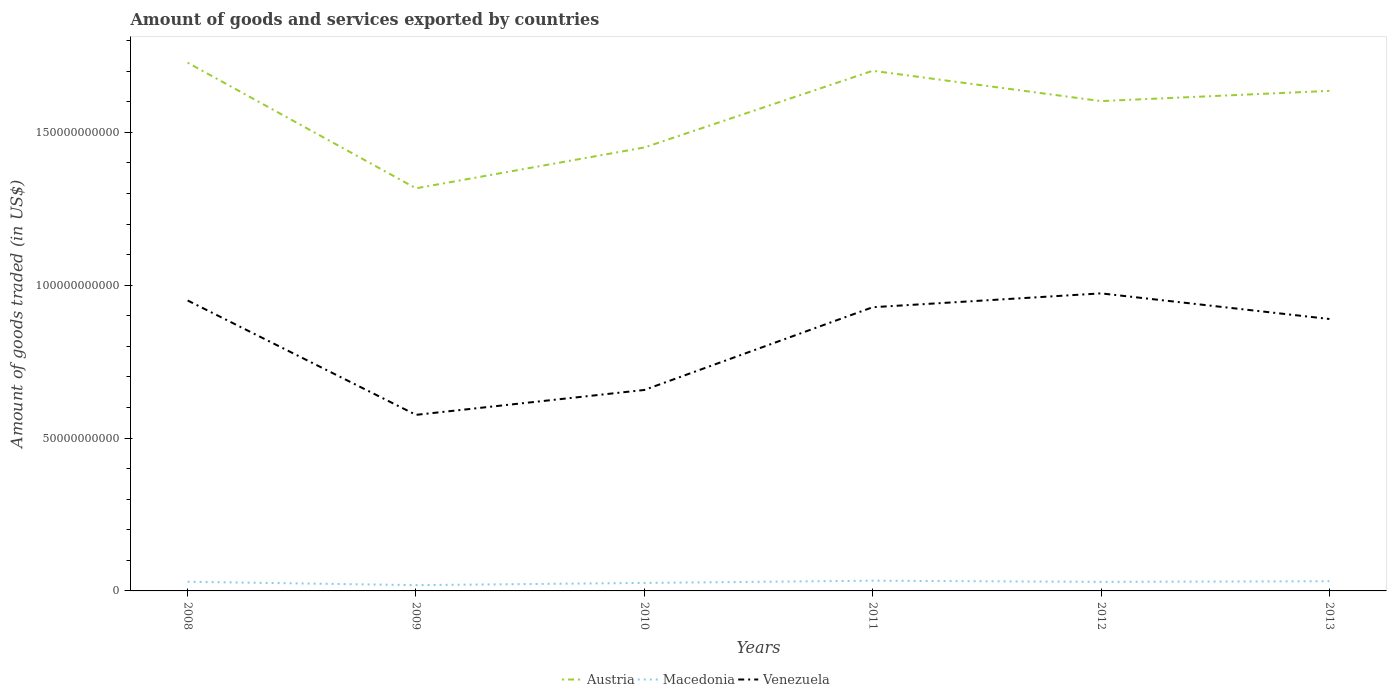Does the line corresponding to Austria intersect with the line corresponding to Macedonia?
Offer a very short reply. No. Is the number of lines equal to the number of legend labels?
Offer a terse response. Yes. Across all years, what is the maximum total amount of goods and services exported in Austria?
Your answer should be compact. 1.32e+11. What is the total total amount of goods and services exported in Austria in the graph?
Your answer should be compact. 9.22e+09. What is the difference between the highest and the second highest total amount of goods and services exported in Austria?
Offer a terse response. 4.11e+1. What is the difference between the highest and the lowest total amount of goods and services exported in Austria?
Provide a succinct answer. 4. How many lines are there?
Offer a very short reply. 3. How many years are there in the graph?
Provide a succinct answer. 6. Does the graph contain any zero values?
Your response must be concise. No. Where does the legend appear in the graph?
Make the answer very short. Bottom center. How are the legend labels stacked?
Provide a succinct answer. Horizontal. What is the title of the graph?
Ensure brevity in your answer.  Amount of goods and services exported by countries. Does "Least developed countries" appear as one of the legend labels in the graph?
Provide a succinct answer. No. What is the label or title of the Y-axis?
Make the answer very short. Amount of goods traded (in US$). What is the Amount of goods traded (in US$) of Austria in 2008?
Your answer should be very brief. 1.73e+11. What is the Amount of goods traded (in US$) of Macedonia in 2008?
Keep it short and to the point. 3.00e+09. What is the Amount of goods traded (in US$) in Venezuela in 2008?
Keep it short and to the point. 9.50e+1. What is the Amount of goods traded (in US$) of Austria in 2009?
Provide a succinct answer. 1.32e+11. What is the Amount of goods traded (in US$) of Macedonia in 2009?
Offer a terse response. 1.89e+09. What is the Amount of goods traded (in US$) in Venezuela in 2009?
Offer a terse response. 5.76e+1. What is the Amount of goods traded (in US$) of Austria in 2010?
Your answer should be compact. 1.45e+11. What is the Amount of goods traded (in US$) in Macedonia in 2010?
Offer a very short reply. 2.62e+09. What is the Amount of goods traded (in US$) in Venezuela in 2010?
Give a very brief answer. 6.57e+1. What is the Amount of goods traded (in US$) in Austria in 2011?
Keep it short and to the point. 1.70e+11. What is the Amount of goods traded (in US$) in Macedonia in 2011?
Your response must be concise. 3.34e+09. What is the Amount of goods traded (in US$) of Venezuela in 2011?
Your answer should be compact. 9.28e+1. What is the Amount of goods traded (in US$) in Austria in 2012?
Ensure brevity in your answer.  1.60e+11. What is the Amount of goods traded (in US$) of Macedonia in 2012?
Offer a terse response. 2.96e+09. What is the Amount of goods traded (in US$) of Venezuela in 2012?
Ensure brevity in your answer.  9.73e+1. What is the Amount of goods traded (in US$) of Austria in 2013?
Make the answer very short. 1.64e+11. What is the Amount of goods traded (in US$) in Macedonia in 2013?
Your answer should be very brief. 3.17e+09. What is the Amount of goods traded (in US$) in Venezuela in 2013?
Provide a succinct answer. 8.90e+1. Across all years, what is the maximum Amount of goods traded (in US$) in Austria?
Your answer should be compact. 1.73e+11. Across all years, what is the maximum Amount of goods traded (in US$) of Macedonia?
Ensure brevity in your answer.  3.34e+09. Across all years, what is the maximum Amount of goods traded (in US$) in Venezuela?
Your answer should be compact. 9.73e+1. Across all years, what is the minimum Amount of goods traded (in US$) in Austria?
Provide a succinct answer. 1.32e+11. Across all years, what is the minimum Amount of goods traded (in US$) in Macedonia?
Your answer should be very brief. 1.89e+09. Across all years, what is the minimum Amount of goods traded (in US$) in Venezuela?
Provide a short and direct response. 5.76e+1. What is the total Amount of goods traded (in US$) of Austria in the graph?
Keep it short and to the point. 9.44e+11. What is the total Amount of goods traded (in US$) in Macedonia in the graph?
Your response must be concise. 1.70e+1. What is the total Amount of goods traded (in US$) of Venezuela in the graph?
Offer a very short reply. 4.97e+11. What is the difference between the Amount of goods traded (in US$) of Austria in 2008 and that in 2009?
Offer a very short reply. 4.11e+1. What is the difference between the Amount of goods traded (in US$) of Macedonia in 2008 and that in 2009?
Ensure brevity in your answer.  1.10e+09. What is the difference between the Amount of goods traded (in US$) in Venezuela in 2008 and that in 2009?
Offer a very short reply. 3.74e+1. What is the difference between the Amount of goods traded (in US$) in Austria in 2008 and that in 2010?
Offer a very short reply. 2.77e+1. What is the difference between the Amount of goods traded (in US$) of Macedonia in 2008 and that in 2010?
Provide a short and direct response. 3.79e+08. What is the difference between the Amount of goods traded (in US$) in Venezuela in 2008 and that in 2010?
Your answer should be compact. 2.93e+1. What is the difference between the Amount of goods traded (in US$) of Austria in 2008 and that in 2011?
Provide a succinct answer. 2.64e+09. What is the difference between the Amount of goods traded (in US$) of Macedonia in 2008 and that in 2011?
Ensure brevity in your answer.  -3.42e+08. What is the difference between the Amount of goods traded (in US$) in Venezuela in 2008 and that in 2011?
Your answer should be compact. 2.21e+09. What is the difference between the Amount of goods traded (in US$) in Austria in 2008 and that in 2012?
Your answer should be compact. 1.26e+1. What is the difference between the Amount of goods traded (in US$) of Macedonia in 2008 and that in 2012?
Your answer should be very brief. 3.56e+07. What is the difference between the Amount of goods traded (in US$) in Venezuela in 2008 and that in 2012?
Your answer should be compact. -2.32e+09. What is the difference between the Amount of goods traded (in US$) of Austria in 2008 and that in 2013?
Provide a succinct answer. 9.22e+09. What is the difference between the Amount of goods traded (in US$) in Macedonia in 2008 and that in 2013?
Keep it short and to the point. -1.70e+08. What is the difference between the Amount of goods traded (in US$) of Venezuela in 2008 and that in 2013?
Give a very brief answer. 6.06e+09. What is the difference between the Amount of goods traded (in US$) of Austria in 2009 and that in 2010?
Your answer should be compact. -1.34e+1. What is the difference between the Amount of goods traded (in US$) in Macedonia in 2009 and that in 2010?
Ensure brevity in your answer.  -7.25e+08. What is the difference between the Amount of goods traded (in US$) of Venezuela in 2009 and that in 2010?
Offer a terse response. -8.14e+09. What is the difference between the Amount of goods traded (in US$) in Austria in 2009 and that in 2011?
Your answer should be very brief. -3.84e+1. What is the difference between the Amount of goods traded (in US$) of Macedonia in 2009 and that in 2011?
Your answer should be compact. -1.45e+09. What is the difference between the Amount of goods traded (in US$) of Venezuela in 2009 and that in 2011?
Provide a succinct answer. -3.52e+1. What is the difference between the Amount of goods traded (in US$) of Austria in 2009 and that in 2012?
Give a very brief answer. -2.85e+1. What is the difference between the Amount of goods traded (in US$) of Macedonia in 2009 and that in 2012?
Offer a very short reply. -1.07e+09. What is the difference between the Amount of goods traded (in US$) of Venezuela in 2009 and that in 2012?
Your answer should be very brief. -3.97e+1. What is the difference between the Amount of goods traded (in US$) of Austria in 2009 and that in 2013?
Your answer should be very brief. -3.19e+1. What is the difference between the Amount of goods traded (in US$) in Macedonia in 2009 and that in 2013?
Provide a succinct answer. -1.27e+09. What is the difference between the Amount of goods traded (in US$) of Venezuela in 2009 and that in 2013?
Provide a short and direct response. -3.14e+1. What is the difference between the Amount of goods traded (in US$) in Austria in 2010 and that in 2011?
Give a very brief answer. -2.51e+1. What is the difference between the Amount of goods traded (in US$) in Macedonia in 2010 and that in 2011?
Ensure brevity in your answer.  -7.21e+08. What is the difference between the Amount of goods traded (in US$) of Venezuela in 2010 and that in 2011?
Offer a very short reply. -2.71e+1. What is the difference between the Amount of goods traded (in US$) of Austria in 2010 and that in 2012?
Keep it short and to the point. -1.52e+1. What is the difference between the Amount of goods traded (in US$) in Macedonia in 2010 and that in 2012?
Offer a terse response. -3.44e+08. What is the difference between the Amount of goods traded (in US$) in Venezuela in 2010 and that in 2012?
Offer a terse response. -3.16e+1. What is the difference between the Amount of goods traded (in US$) of Austria in 2010 and that in 2013?
Your answer should be compact. -1.85e+1. What is the difference between the Amount of goods traded (in US$) in Macedonia in 2010 and that in 2013?
Your answer should be very brief. -5.49e+08. What is the difference between the Amount of goods traded (in US$) in Venezuela in 2010 and that in 2013?
Provide a succinct answer. -2.32e+1. What is the difference between the Amount of goods traded (in US$) of Austria in 2011 and that in 2012?
Offer a terse response. 9.92e+09. What is the difference between the Amount of goods traded (in US$) in Macedonia in 2011 and that in 2012?
Your answer should be very brief. 3.78e+08. What is the difference between the Amount of goods traded (in US$) in Venezuela in 2011 and that in 2012?
Ensure brevity in your answer.  -4.53e+09. What is the difference between the Amount of goods traded (in US$) of Austria in 2011 and that in 2013?
Ensure brevity in your answer.  6.57e+09. What is the difference between the Amount of goods traded (in US$) of Macedonia in 2011 and that in 2013?
Your answer should be compact. 1.72e+08. What is the difference between the Amount of goods traded (in US$) of Venezuela in 2011 and that in 2013?
Your answer should be very brief. 3.85e+09. What is the difference between the Amount of goods traded (in US$) in Austria in 2012 and that in 2013?
Your answer should be very brief. -3.34e+09. What is the difference between the Amount of goods traded (in US$) of Macedonia in 2012 and that in 2013?
Make the answer very short. -2.06e+08. What is the difference between the Amount of goods traded (in US$) of Venezuela in 2012 and that in 2013?
Keep it short and to the point. 8.38e+09. What is the difference between the Amount of goods traded (in US$) in Austria in 2008 and the Amount of goods traded (in US$) in Macedonia in 2009?
Make the answer very short. 1.71e+11. What is the difference between the Amount of goods traded (in US$) in Austria in 2008 and the Amount of goods traded (in US$) in Venezuela in 2009?
Provide a succinct answer. 1.15e+11. What is the difference between the Amount of goods traded (in US$) in Macedonia in 2008 and the Amount of goods traded (in US$) in Venezuela in 2009?
Provide a short and direct response. -5.46e+1. What is the difference between the Amount of goods traded (in US$) in Austria in 2008 and the Amount of goods traded (in US$) in Macedonia in 2010?
Keep it short and to the point. 1.70e+11. What is the difference between the Amount of goods traded (in US$) in Austria in 2008 and the Amount of goods traded (in US$) in Venezuela in 2010?
Provide a short and direct response. 1.07e+11. What is the difference between the Amount of goods traded (in US$) of Macedonia in 2008 and the Amount of goods traded (in US$) of Venezuela in 2010?
Your response must be concise. -6.27e+1. What is the difference between the Amount of goods traded (in US$) of Austria in 2008 and the Amount of goods traded (in US$) of Macedonia in 2011?
Your response must be concise. 1.69e+11. What is the difference between the Amount of goods traded (in US$) of Austria in 2008 and the Amount of goods traded (in US$) of Venezuela in 2011?
Make the answer very short. 8.00e+1. What is the difference between the Amount of goods traded (in US$) in Macedonia in 2008 and the Amount of goods traded (in US$) in Venezuela in 2011?
Your response must be concise. -8.98e+1. What is the difference between the Amount of goods traded (in US$) in Austria in 2008 and the Amount of goods traded (in US$) in Macedonia in 2012?
Your answer should be compact. 1.70e+11. What is the difference between the Amount of goods traded (in US$) of Austria in 2008 and the Amount of goods traded (in US$) of Venezuela in 2012?
Offer a very short reply. 7.55e+1. What is the difference between the Amount of goods traded (in US$) of Macedonia in 2008 and the Amount of goods traded (in US$) of Venezuela in 2012?
Keep it short and to the point. -9.43e+1. What is the difference between the Amount of goods traded (in US$) of Austria in 2008 and the Amount of goods traded (in US$) of Macedonia in 2013?
Offer a terse response. 1.70e+11. What is the difference between the Amount of goods traded (in US$) in Austria in 2008 and the Amount of goods traded (in US$) in Venezuela in 2013?
Provide a short and direct response. 8.38e+1. What is the difference between the Amount of goods traded (in US$) in Macedonia in 2008 and the Amount of goods traded (in US$) in Venezuela in 2013?
Keep it short and to the point. -8.60e+1. What is the difference between the Amount of goods traded (in US$) in Austria in 2009 and the Amount of goods traded (in US$) in Macedonia in 2010?
Keep it short and to the point. 1.29e+11. What is the difference between the Amount of goods traded (in US$) in Austria in 2009 and the Amount of goods traded (in US$) in Venezuela in 2010?
Make the answer very short. 6.60e+1. What is the difference between the Amount of goods traded (in US$) in Macedonia in 2009 and the Amount of goods traded (in US$) in Venezuela in 2010?
Give a very brief answer. -6.38e+1. What is the difference between the Amount of goods traded (in US$) in Austria in 2009 and the Amount of goods traded (in US$) in Macedonia in 2011?
Your answer should be very brief. 1.28e+11. What is the difference between the Amount of goods traded (in US$) of Austria in 2009 and the Amount of goods traded (in US$) of Venezuela in 2011?
Your answer should be compact. 3.89e+1. What is the difference between the Amount of goods traded (in US$) of Macedonia in 2009 and the Amount of goods traded (in US$) of Venezuela in 2011?
Provide a succinct answer. -9.09e+1. What is the difference between the Amount of goods traded (in US$) of Austria in 2009 and the Amount of goods traded (in US$) of Macedonia in 2012?
Make the answer very short. 1.29e+11. What is the difference between the Amount of goods traded (in US$) of Austria in 2009 and the Amount of goods traded (in US$) of Venezuela in 2012?
Make the answer very short. 3.44e+1. What is the difference between the Amount of goods traded (in US$) of Macedonia in 2009 and the Amount of goods traded (in US$) of Venezuela in 2012?
Give a very brief answer. -9.54e+1. What is the difference between the Amount of goods traded (in US$) in Austria in 2009 and the Amount of goods traded (in US$) in Macedonia in 2013?
Offer a very short reply. 1.29e+11. What is the difference between the Amount of goods traded (in US$) in Austria in 2009 and the Amount of goods traded (in US$) in Venezuela in 2013?
Keep it short and to the point. 4.28e+1. What is the difference between the Amount of goods traded (in US$) of Macedonia in 2009 and the Amount of goods traded (in US$) of Venezuela in 2013?
Make the answer very short. -8.71e+1. What is the difference between the Amount of goods traded (in US$) in Austria in 2010 and the Amount of goods traded (in US$) in Macedonia in 2011?
Make the answer very short. 1.42e+11. What is the difference between the Amount of goods traded (in US$) of Austria in 2010 and the Amount of goods traded (in US$) of Venezuela in 2011?
Offer a terse response. 5.23e+1. What is the difference between the Amount of goods traded (in US$) in Macedonia in 2010 and the Amount of goods traded (in US$) in Venezuela in 2011?
Your response must be concise. -9.02e+1. What is the difference between the Amount of goods traded (in US$) in Austria in 2010 and the Amount of goods traded (in US$) in Macedonia in 2012?
Provide a succinct answer. 1.42e+11. What is the difference between the Amount of goods traded (in US$) of Austria in 2010 and the Amount of goods traded (in US$) of Venezuela in 2012?
Offer a terse response. 4.77e+1. What is the difference between the Amount of goods traded (in US$) in Macedonia in 2010 and the Amount of goods traded (in US$) in Venezuela in 2012?
Offer a terse response. -9.47e+1. What is the difference between the Amount of goods traded (in US$) in Austria in 2010 and the Amount of goods traded (in US$) in Macedonia in 2013?
Your response must be concise. 1.42e+11. What is the difference between the Amount of goods traded (in US$) in Austria in 2010 and the Amount of goods traded (in US$) in Venezuela in 2013?
Your response must be concise. 5.61e+1. What is the difference between the Amount of goods traded (in US$) of Macedonia in 2010 and the Amount of goods traded (in US$) of Venezuela in 2013?
Offer a very short reply. -8.63e+1. What is the difference between the Amount of goods traded (in US$) of Austria in 2011 and the Amount of goods traded (in US$) of Macedonia in 2012?
Your answer should be very brief. 1.67e+11. What is the difference between the Amount of goods traded (in US$) of Austria in 2011 and the Amount of goods traded (in US$) of Venezuela in 2012?
Your answer should be very brief. 7.28e+1. What is the difference between the Amount of goods traded (in US$) in Macedonia in 2011 and the Amount of goods traded (in US$) in Venezuela in 2012?
Your answer should be compact. -9.40e+1. What is the difference between the Amount of goods traded (in US$) of Austria in 2011 and the Amount of goods traded (in US$) of Macedonia in 2013?
Ensure brevity in your answer.  1.67e+11. What is the difference between the Amount of goods traded (in US$) in Austria in 2011 and the Amount of goods traded (in US$) in Venezuela in 2013?
Provide a short and direct response. 8.12e+1. What is the difference between the Amount of goods traded (in US$) in Macedonia in 2011 and the Amount of goods traded (in US$) in Venezuela in 2013?
Offer a very short reply. -8.56e+1. What is the difference between the Amount of goods traded (in US$) in Austria in 2012 and the Amount of goods traded (in US$) in Macedonia in 2013?
Give a very brief answer. 1.57e+11. What is the difference between the Amount of goods traded (in US$) of Austria in 2012 and the Amount of goods traded (in US$) of Venezuela in 2013?
Your answer should be very brief. 7.13e+1. What is the difference between the Amount of goods traded (in US$) in Macedonia in 2012 and the Amount of goods traded (in US$) in Venezuela in 2013?
Make the answer very short. -8.60e+1. What is the average Amount of goods traded (in US$) of Austria per year?
Provide a succinct answer. 1.57e+11. What is the average Amount of goods traded (in US$) of Macedonia per year?
Ensure brevity in your answer.  2.83e+09. What is the average Amount of goods traded (in US$) of Venezuela per year?
Give a very brief answer. 8.29e+1. In the year 2008, what is the difference between the Amount of goods traded (in US$) in Austria and Amount of goods traded (in US$) in Macedonia?
Provide a short and direct response. 1.70e+11. In the year 2008, what is the difference between the Amount of goods traded (in US$) of Austria and Amount of goods traded (in US$) of Venezuela?
Give a very brief answer. 7.78e+1. In the year 2008, what is the difference between the Amount of goods traded (in US$) in Macedonia and Amount of goods traded (in US$) in Venezuela?
Offer a terse response. -9.20e+1. In the year 2009, what is the difference between the Amount of goods traded (in US$) in Austria and Amount of goods traded (in US$) in Macedonia?
Offer a very short reply. 1.30e+11. In the year 2009, what is the difference between the Amount of goods traded (in US$) in Austria and Amount of goods traded (in US$) in Venezuela?
Provide a succinct answer. 7.41e+1. In the year 2009, what is the difference between the Amount of goods traded (in US$) of Macedonia and Amount of goods traded (in US$) of Venezuela?
Your response must be concise. -5.57e+1. In the year 2010, what is the difference between the Amount of goods traded (in US$) in Austria and Amount of goods traded (in US$) in Macedonia?
Ensure brevity in your answer.  1.42e+11. In the year 2010, what is the difference between the Amount of goods traded (in US$) of Austria and Amount of goods traded (in US$) of Venezuela?
Offer a terse response. 7.93e+1. In the year 2010, what is the difference between the Amount of goods traded (in US$) in Macedonia and Amount of goods traded (in US$) in Venezuela?
Ensure brevity in your answer.  -6.31e+1. In the year 2011, what is the difference between the Amount of goods traded (in US$) of Austria and Amount of goods traded (in US$) of Macedonia?
Your answer should be compact. 1.67e+11. In the year 2011, what is the difference between the Amount of goods traded (in US$) in Austria and Amount of goods traded (in US$) in Venezuela?
Keep it short and to the point. 7.74e+1. In the year 2011, what is the difference between the Amount of goods traded (in US$) in Macedonia and Amount of goods traded (in US$) in Venezuela?
Offer a terse response. -8.95e+1. In the year 2012, what is the difference between the Amount of goods traded (in US$) in Austria and Amount of goods traded (in US$) in Macedonia?
Keep it short and to the point. 1.57e+11. In the year 2012, what is the difference between the Amount of goods traded (in US$) of Austria and Amount of goods traded (in US$) of Venezuela?
Keep it short and to the point. 6.29e+1. In the year 2012, what is the difference between the Amount of goods traded (in US$) in Macedonia and Amount of goods traded (in US$) in Venezuela?
Provide a succinct answer. -9.44e+1. In the year 2013, what is the difference between the Amount of goods traded (in US$) of Austria and Amount of goods traded (in US$) of Macedonia?
Offer a terse response. 1.60e+11. In the year 2013, what is the difference between the Amount of goods traded (in US$) in Austria and Amount of goods traded (in US$) in Venezuela?
Ensure brevity in your answer.  7.46e+1. In the year 2013, what is the difference between the Amount of goods traded (in US$) in Macedonia and Amount of goods traded (in US$) in Venezuela?
Give a very brief answer. -8.58e+1. What is the ratio of the Amount of goods traded (in US$) in Austria in 2008 to that in 2009?
Make the answer very short. 1.31. What is the ratio of the Amount of goods traded (in US$) of Macedonia in 2008 to that in 2009?
Provide a succinct answer. 1.58. What is the ratio of the Amount of goods traded (in US$) in Venezuela in 2008 to that in 2009?
Provide a succinct answer. 1.65. What is the ratio of the Amount of goods traded (in US$) in Austria in 2008 to that in 2010?
Make the answer very short. 1.19. What is the ratio of the Amount of goods traded (in US$) of Macedonia in 2008 to that in 2010?
Ensure brevity in your answer.  1.14. What is the ratio of the Amount of goods traded (in US$) of Venezuela in 2008 to that in 2010?
Provide a succinct answer. 1.45. What is the ratio of the Amount of goods traded (in US$) in Austria in 2008 to that in 2011?
Your answer should be compact. 1.02. What is the ratio of the Amount of goods traded (in US$) in Macedonia in 2008 to that in 2011?
Ensure brevity in your answer.  0.9. What is the ratio of the Amount of goods traded (in US$) in Venezuela in 2008 to that in 2011?
Provide a succinct answer. 1.02. What is the ratio of the Amount of goods traded (in US$) in Austria in 2008 to that in 2012?
Give a very brief answer. 1.08. What is the ratio of the Amount of goods traded (in US$) in Venezuela in 2008 to that in 2012?
Keep it short and to the point. 0.98. What is the ratio of the Amount of goods traded (in US$) of Austria in 2008 to that in 2013?
Make the answer very short. 1.06. What is the ratio of the Amount of goods traded (in US$) of Macedonia in 2008 to that in 2013?
Provide a short and direct response. 0.95. What is the ratio of the Amount of goods traded (in US$) of Venezuela in 2008 to that in 2013?
Provide a succinct answer. 1.07. What is the ratio of the Amount of goods traded (in US$) of Austria in 2009 to that in 2010?
Your response must be concise. 0.91. What is the ratio of the Amount of goods traded (in US$) of Macedonia in 2009 to that in 2010?
Provide a short and direct response. 0.72. What is the ratio of the Amount of goods traded (in US$) in Venezuela in 2009 to that in 2010?
Your answer should be compact. 0.88. What is the ratio of the Amount of goods traded (in US$) in Austria in 2009 to that in 2011?
Provide a succinct answer. 0.77. What is the ratio of the Amount of goods traded (in US$) in Macedonia in 2009 to that in 2011?
Keep it short and to the point. 0.57. What is the ratio of the Amount of goods traded (in US$) in Venezuela in 2009 to that in 2011?
Ensure brevity in your answer.  0.62. What is the ratio of the Amount of goods traded (in US$) of Austria in 2009 to that in 2012?
Give a very brief answer. 0.82. What is the ratio of the Amount of goods traded (in US$) in Macedonia in 2009 to that in 2012?
Provide a short and direct response. 0.64. What is the ratio of the Amount of goods traded (in US$) in Venezuela in 2009 to that in 2012?
Offer a very short reply. 0.59. What is the ratio of the Amount of goods traded (in US$) in Austria in 2009 to that in 2013?
Keep it short and to the point. 0.81. What is the ratio of the Amount of goods traded (in US$) in Macedonia in 2009 to that in 2013?
Keep it short and to the point. 0.6. What is the ratio of the Amount of goods traded (in US$) of Venezuela in 2009 to that in 2013?
Give a very brief answer. 0.65. What is the ratio of the Amount of goods traded (in US$) in Austria in 2010 to that in 2011?
Make the answer very short. 0.85. What is the ratio of the Amount of goods traded (in US$) in Macedonia in 2010 to that in 2011?
Your answer should be compact. 0.78. What is the ratio of the Amount of goods traded (in US$) of Venezuela in 2010 to that in 2011?
Offer a terse response. 0.71. What is the ratio of the Amount of goods traded (in US$) of Austria in 2010 to that in 2012?
Offer a very short reply. 0.91. What is the ratio of the Amount of goods traded (in US$) in Macedonia in 2010 to that in 2012?
Give a very brief answer. 0.88. What is the ratio of the Amount of goods traded (in US$) of Venezuela in 2010 to that in 2012?
Make the answer very short. 0.68. What is the ratio of the Amount of goods traded (in US$) in Austria in 2010 to that in 2013?
Provide a succinct answer. 0.89. What is the ratio of the Amount of goods traded (in US$) in Macedonia in 2010 to that in 2013?
Offer a terse response. 0.83. What is the ratio of the Amount of goods traded (in US$) in Venezuela in 2010 to that in 2013?
Ensure brevity in your answer.  0.74. What is the ratio of the Amount of goods traded (in US$) of Austria in 2011 to that in 2012?
Provide a short and direct response. 1.06. What is the ratio of the Amount of goods traded (in US$) in Macedonia in 2011 to that in 2012?
Offer a very short reply. 1.13. What is the ratio of the Amount of goods traded (in US$) of Venezuela in 2011 to that in 2012?
Make the answer very short. 0.95. What is the ratio of the Amount of goods traded (in US$) of Austria in 2011 to that in 2013?
Your answer should be very brief. 1.04. What is the ratio of the Amount of goods traded (in US$) in Macedonia in 2011 to that in 2013?
Your answer should be very brief. 1.05. What is the ratio of the Amount of goods traded (in US$) of Venezuela in 2011 to that in 2013?
Keep it short and to the point. 1.04. What is the ratio of the Amount of goods traded (in US$) of Austria in 2012 to that in 2013?
Keep it short and to the point. 0.98. What is the ratio of the Amount of goods traded (in US$) in Macedonia in 2012 to that in 2013?
Ensure brevity in your answer.  0.94. What is the ratio of the Amount of goods traded (in US$) in Venezuela in 2012 to that in 2013?
Keep it short and to the point. 1.09. What is the difference between the highest and the second highest Amount of goods traded (in US$) in Austria?
Ensure brevity in your answer.  2.64e+09. What is the difference between the highest and the second highest Amount of goods traded (in US$) of Macedonia?
Provide a succinct answer. 1.72e+08. What is the difference between the highest and the second highest Amount of goods traded (in US$) of Venezuela?
Provide a succinct answer. 2.32e+09. What is the difference between the highest and the lowest Amount of goods traded (in US$) in Austria?
Offer a very short reply. 4.11e+1. What is the difference between the highest and the lowest Amount of goods traded (in US$) in Macedonia?
Offer a terse response. 1.45e+09. What is the difference between the highest and the lowest Amount of goods traded (in US$) of Venezuela?
Give a very brief answer. 3.97e+1. 